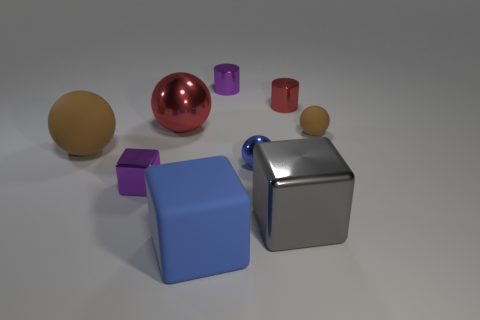Subtract 1 spheres. How many spheres are left? 3 Subtract all cyan balls. Subtract all brown cylinders. How many balls are left? 4 Add 1 small purple cylinders. How many objects exist? 10 Subtract all spheres. How many objects are left? 5 Subtract 1 red spheres. How many objects are left? 8 Subtract all big purple metal spheres. Subtract all metallic cubes. How many objects are left? 7 Add 8 tiny metal cylinders. How many tiny metal cylinders are left? 10 Add 8 tiny red objects. How many tiny red objects exist? 9 